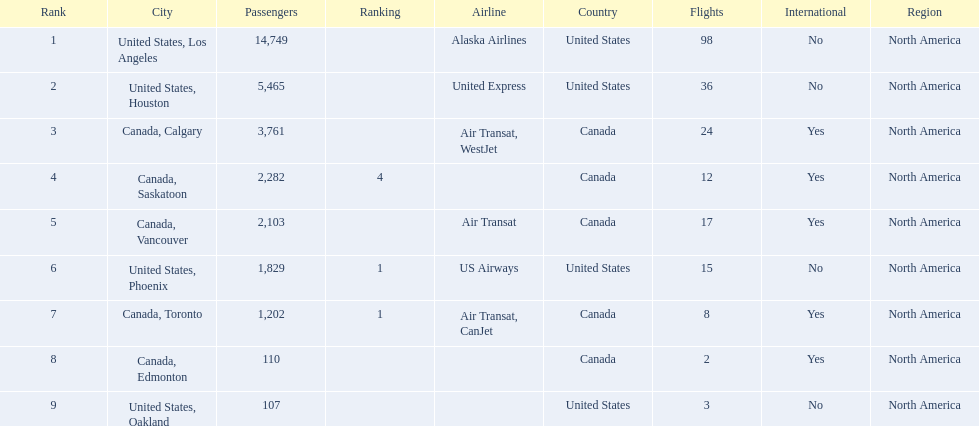Where are the destinations of the airport? United States, Los Angeles, United States, Houston, Canada, Calgary, Canada, Saskatoon, Canada, Vancouver, United States, Phoenix, Canada, Toronto, Canada, Edmonton, United States, Oakland. Parse the table in full. {'header': ['Rank', 'City', 'Passengers', 'Ranking', 'Airline', 'Country', 'Flights', 'International', 'Region'], 'rows': [['1', 'United States, Los Angeles', '14,749', '', 'Alaska Airlines', 'United States', '98', 'No', 'North America'], ['2', 'United States, Houston', '5,465', '', 'United Express', 'United States', '36', 'No', 'North America'], ['3', 'Canada, Calgary', '3,761', '', 'Air Transat, WestJet', 'Canada', '24', 'Yes', 'North America'], ['4', 'Canada, Saskatoon', '2,282', '4', '', 'Canada', '12', 'Yes', 'North America'], ['5', 'Canada, Vancouver', '2,103', '', 'Air Transat', 'Canada', '17', 'Yes', 'North America'], ['6', 'United States, Phoenix', '1,829', '1', 'US Airways', 'United States', '15', 'No', 'North America'], ['7', 'Canada, Toronto', '1,202', '1', 'Air Transat, CanJet', 'Canada', '8', 'Yes', 'North America'], ['8', 'Canada, Edmonton', '110', '', '', 'Canada', '2', 'Yes', 'North America'], ['9', 'United States, Oakland', '107', '', '', 'United States', '3', 'No', 'North America']]} What is the number of passengers to phoenix? 1,829. 